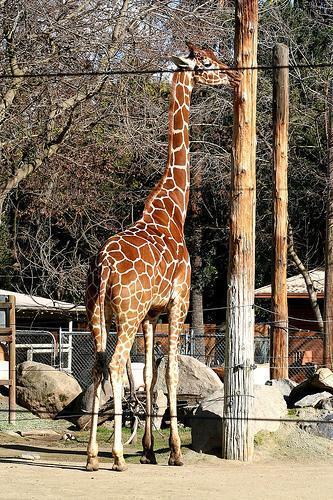How many animals are in the picture?
Give a very brief answer. 1. 